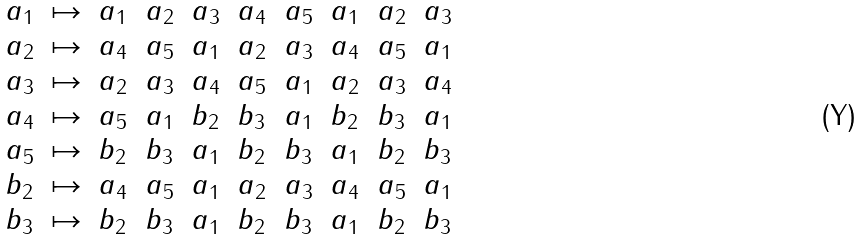Convert formula to latex. <formula><loc_0><loc_0><loc_500><loc_500>\begin{array} { l c l l l l l l l l } a _ { 1 } & \mapsto & a _ { 1 } & a _ { 2 } & a _ { 3 } & a _ { 4 } & a _ { 5 } & a _ { 1 } & a _ { 2 } & a _ { 3 } \\ a _ { 2 } & \mapsto & a _ { 4 } & a _ { 5 } & a _ { 1 } & a _ { 2 } & a _ { 3 } & a _ { 4 } & a _ { 5 } & a _ { 1 } \\ a _ { 3 } & \mapsto & a _ { 2 } & a _ { 3 } & a _ { 4 } & a _ { 5 } & a _ { 1 } & a _ { 2 } & a _ { 3 } & a _ { 4 } \\ a _ { 4 } & \mapsto & a _ { 5 } & a _ { 1 } & b _ { 2 } & b _ { 3 } & a _ { 1 } & b _ { 2 } & b _ { 3 } & a _ { 1 } \\ a _ { 5 } & \mapsto & b _ { 2 } & b _ { 3 } & a _ { 1 } & b _ { 2 } & b _ { 3 } & a _ { 1 } & b _ { 2 } & b _ { 3 } \\ b _ { 2 } & \mapsto & a _ { 4 } & a _ { 5 } & a _ { 1 } & a _ { 2 } & a _ { 3 } & a _ { 4 } & a _ { 5 } & a _ { 1 } \\ b _ { 3 } & \mapsto & b _ { 2 } & b _ { 3 } & a _ { 1 } & b _ { 2 } & b _ { 3 } & a _ { 1 } & b _ { 2 } & b _ { 3 } \\ \end{array}</formula> 